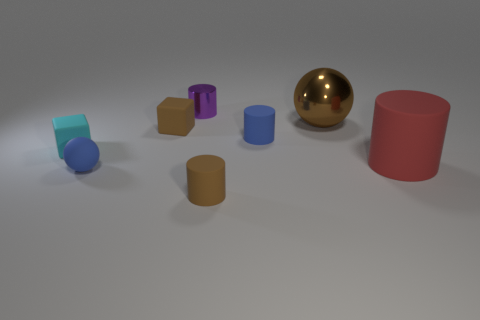There is a matte cylinder that is behind the small rubber cube on the left side of the rubber cube that is right of the tiny cyan matte object; what is its size?
Provide a short and direct response. Small. Do the small cyan thing and the blue matte thing that is behind the small blue ball have the same shape?
Ensure brevity in your answer.  No. How many other things are the same size as the blue matte sphere?
Offer a very short reply. 5. What size is the blue rubber object right of the small purple shiny cylinder?
Your response must be concise. Small. What number of brown spheres have the same material as the blue sphere?
Your answer should be compact. 0. Does the tiny object that is behind the brown metallic thing have the same shape as the brown shiny object?
Your answer should be compact. No. There is a small brown matte thing that is to the right of the small brown rubber cube; what is its shape?
Offer a very short reply. Cylinder. What size is the cylinder that is the same color as the metallic ball?
Your answer should be compact. Small. What is the big sphere made of?
Offer a very short reply. Metal. There is a thing that is the same size as the red cylinder; what color is it?
Your answer should be compact. Brown. 